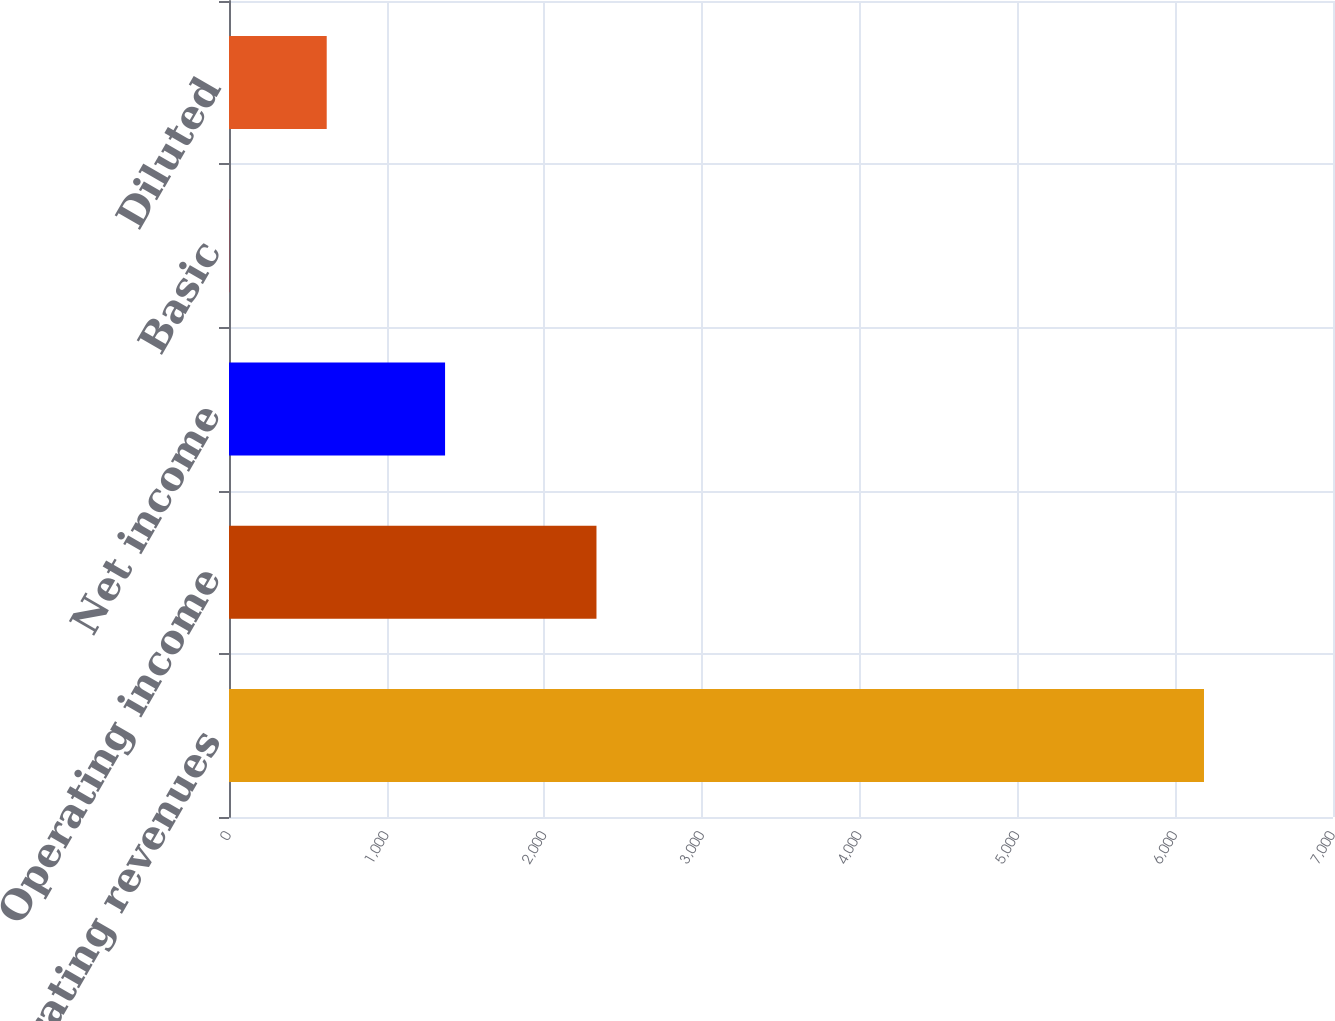<chart> <loc_0><loc_0><loc_500><loc_500><bar_chart><fcel>Operating revenues<fcel>Operating income<fcel>Net income<fcel>Basic<fcel>Diluted<nl><fcel>6182<fcel>2330<fcel>1370<fcel>1.53<fcel>619.58<nl></chart> 